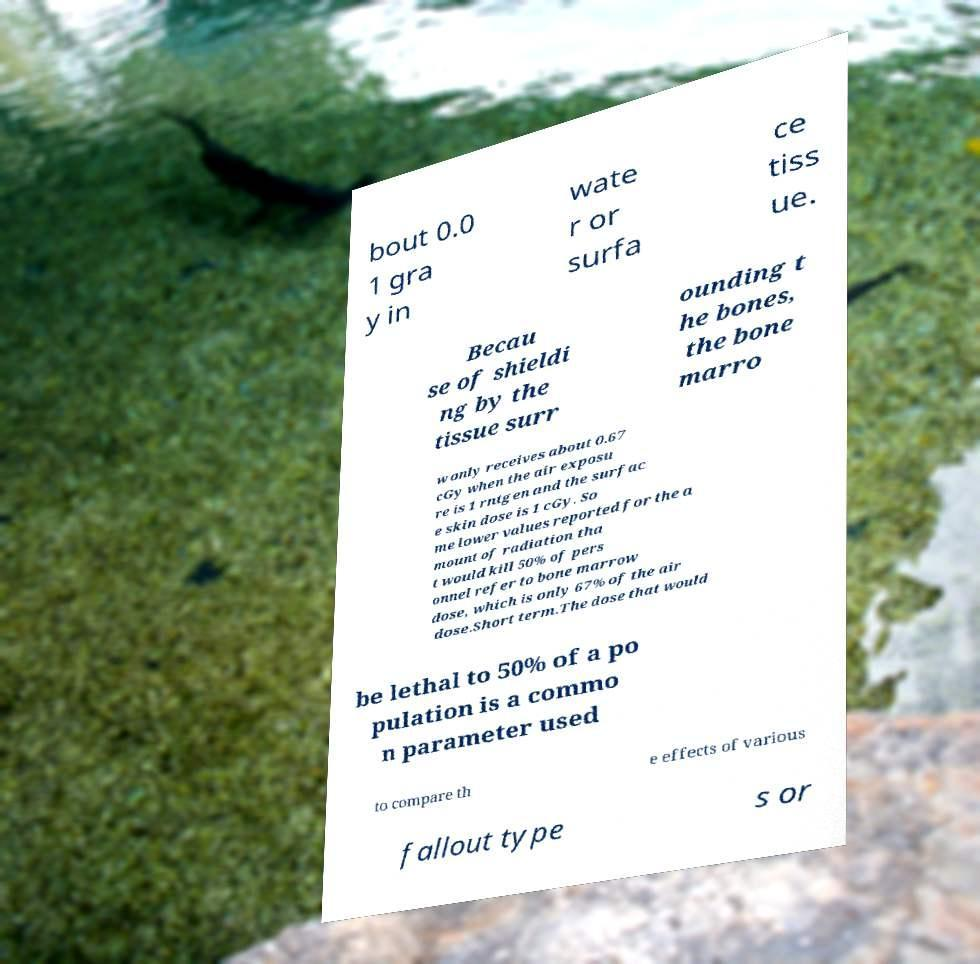There's text embedded in this image that I need extracted. Can you transcribe it verbatim? bout 0.0 1 gra y in wate r or surfa ce tiss ue. Becau se of shieldi ng by the tissue surr ounding t he bones, the bone marro w only receives about 0.67 cGy when the air exposu re is 1 rntgen and the surfac e skin dose is 1 cGy. So me lower values reported for the a mount of radiation tha t would kill 50% of pers onnel refer to bone marrow dose, which is only 67% of the air dose.Short term.The dose that would be lethal to 50% of a po pulation is a commo n parameter used to compare th e effects of various fallout type s or 